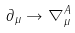<formula> <loc_0><loc_0><loc_500><loc_500>\partial _ { \mu } \to \nabla _ { \mu } ^ { A }</formula> 